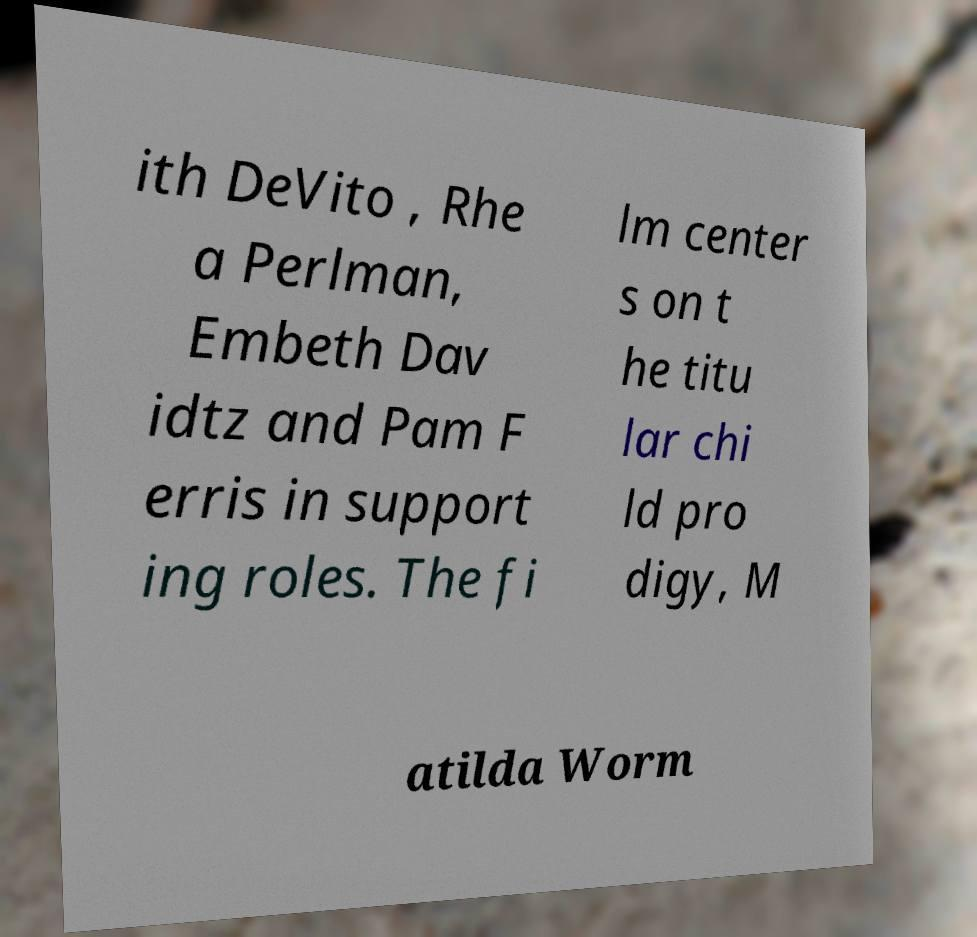For documentation purposes, I need the text within this image transcribed. Could you provide that? ith DeVito , Rhe a Perlman, Embeth Dav idtz and Pam F erris in support ing roles. The fi lm center s on t he titu lar chi ld pro digy, M atilda Worm 